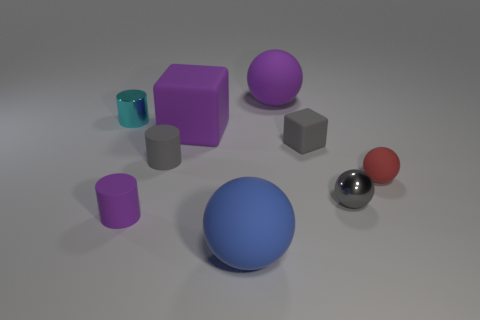What number of large purple objects have the same shape as the blue rubber thing?
Your response must be concise. 1. There is a gray cylinder that is the same size as the gray cube; what is its material?
Ensure brevity in your answer.  Rubber. Is there a cube made of the same material as the small purple object?
Your answer should be compact. Yes. Is the number of tiny gray objects left of the purple rubber cylinder less than the number of small gray blocks?
Give a very brief answer. Yes. What is the material of the big purple thing that is in front of the large ball that is on the right side of the blue rubber object?
Provide a short and direct response. Rubber. There is a tiny thing that is both behind the small rubber ball and to the right of the large blue rubber thing; what is its shape?
Provide a short and direct response. Cube. How many other objects are there of the same color as the large matte block?
Your answer should be compact. 2. What number of things are either metal things that are to the right of the big purple block or balls?
Give a very brief answer. 4. Do the shiny cylinder and the metal object that is on the right side of the tiny cyan metallic thing have the same color?
Make the answer very short. No. Is there any other thing that is the same size as the red thing?
Your response must be concise. Yes. 